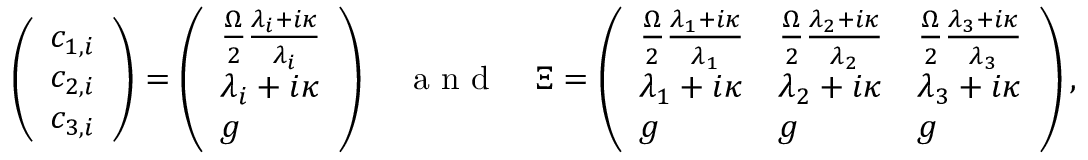Convert formula to latex. <formula><loc_0><loc_0><loc_500><loc_500>\left ( \begin{array} { l } { c _ { 1 , i } } \\ { c _ { 2 , i } } \\ { c _ { 3 , i } } \end{array} \right ) = \left ( \begin{array} { l } { \frac { \Omega } { 2 } \frac { \lambda _ { i } + i \kappa } { \lambda _ { i } } } \\ { \lambda _ { i } + i \kappa } \\ { g } \end{array} \right ) \quad a n d \quad \Xi = \left ( \begin{array} { l l l } { \frac { \Omega } { 2 } \frac { \lambda _ { 1 } + i \kappa } { \lambda _ { 1 } } } & { \frac { \Omega } { 2 } \frac { \lambda _ { 2 } + i \kappa } { \lambda _ { 2 } } } & { \frac { \Omega } { 2 } \frac { \lambda _ { 3 } + i \kappa } { \lambda _ { 3 } } } \\ { \lambda _ { 1 } + i \kappa } & { \lambda _ { 2 } + i \kappa } & { \lambda _ { 3 } + i \kappa } \\ { g } & { g } & { g } \end{array} \right ) ,</formula> 